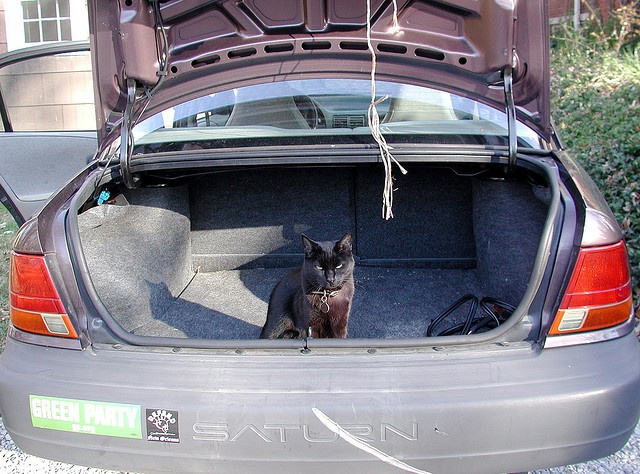Describe the objects in this image and their specific colors. I can see car in darkgray, lightgray, black, gray, and white tones and cat in white, black, gray, and darkgray tones in this image. 